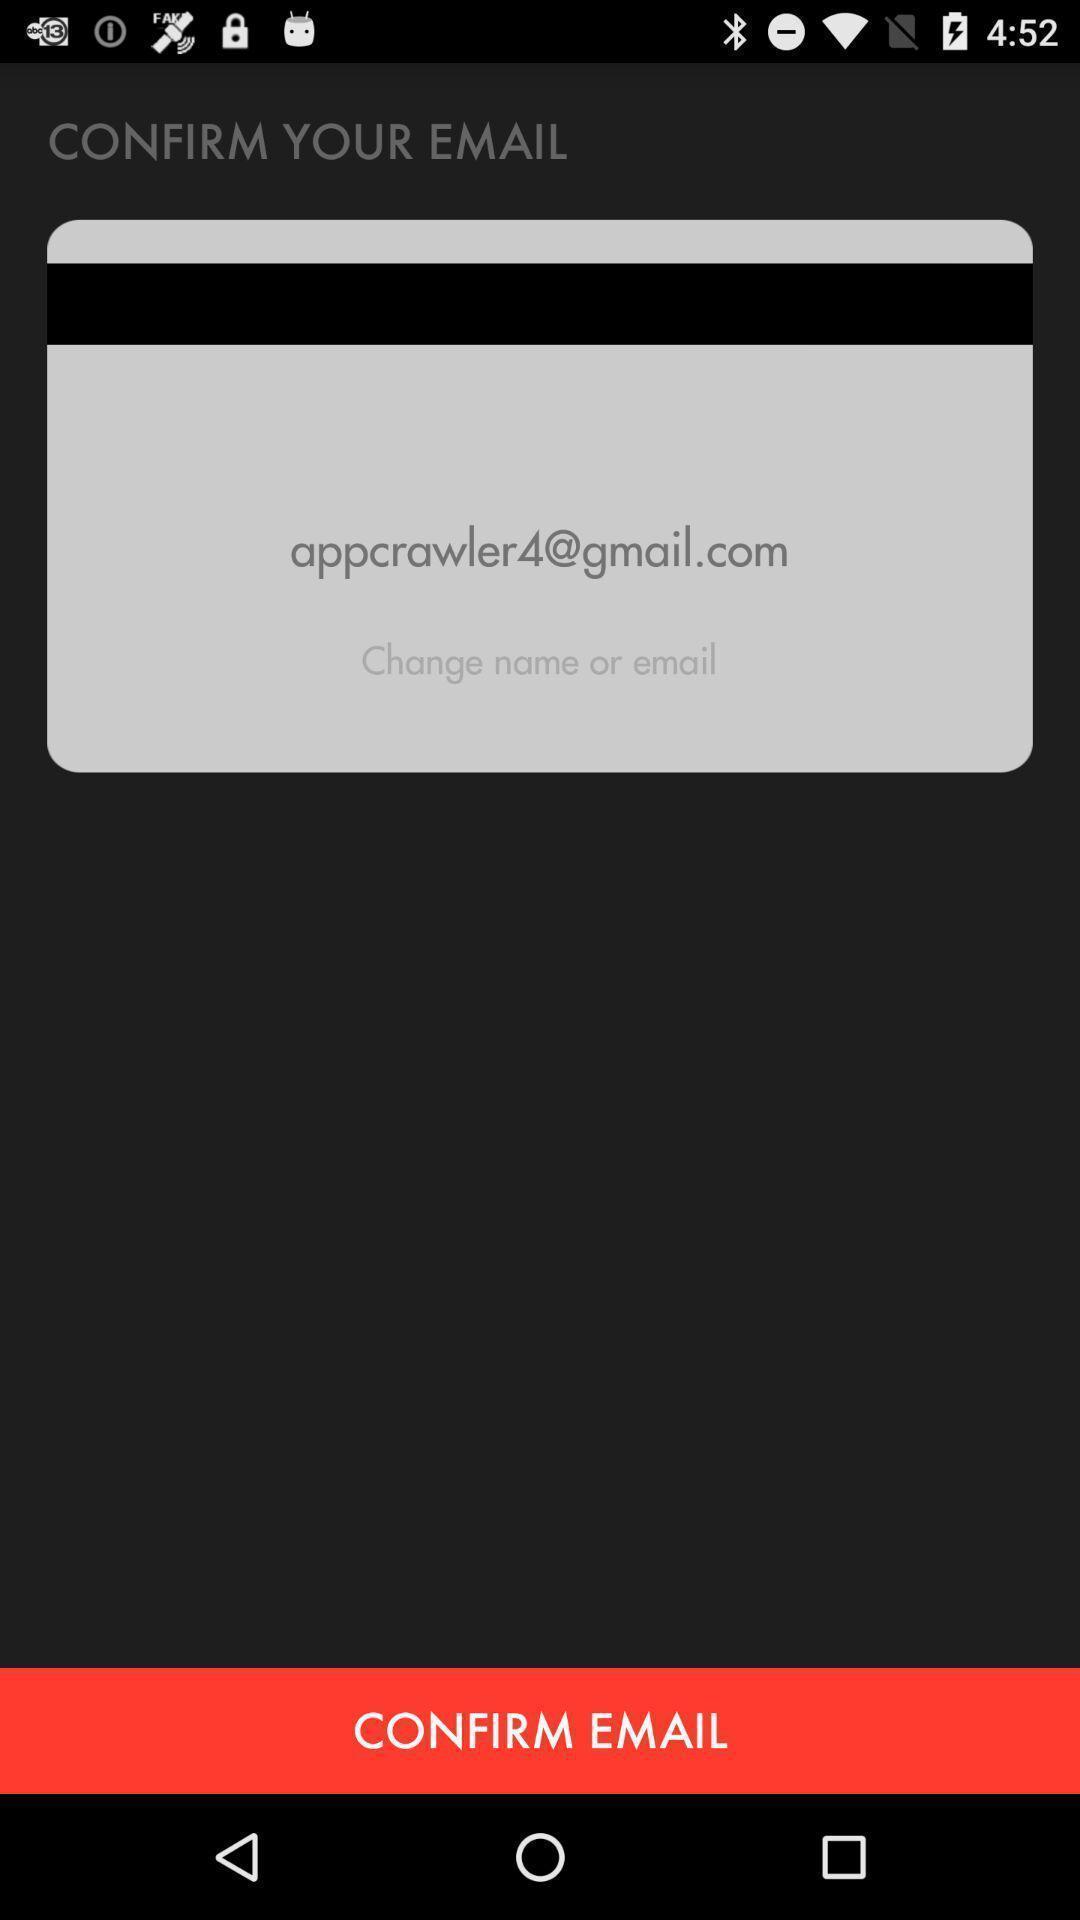Provide a detailed account of this screenshot. Page showing to confirm email in a financial app. 